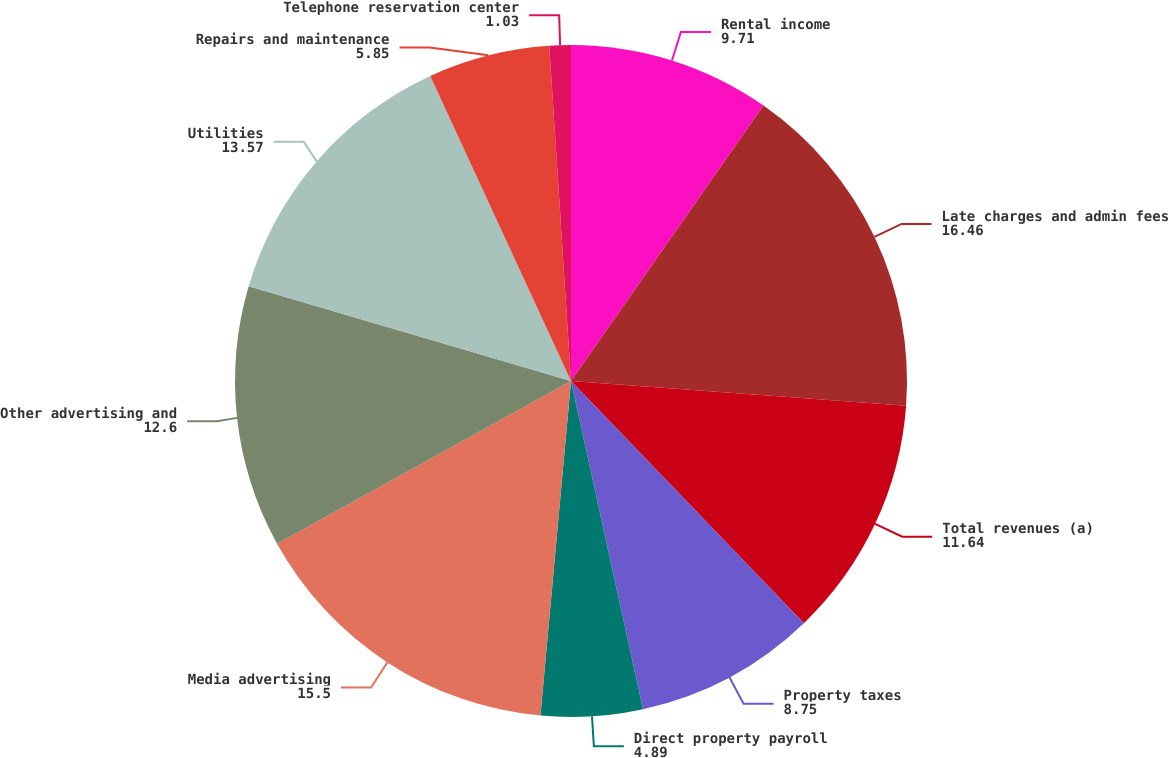Convert chart. <chart><loc_0><loc_0><loc_500><loc_500><pie_chart><fcel>Rental income<fcel>Late charges and admin fees<fcel>Total revenues (a)<fcel>Property taxes<fcel>Direct property payroll<fcel>Media advertising<fcel>Other advertising and<fcel>Utilities<fcel>Repairs and maintenance<fcel>Telephone reservation center<nl><fcel>9.71%<fcel>16.46%<fcel>11.64%<fcel>8.75%<fcel>4.89%<fcel>15.5%<fcel>12.6%<fcel>13.57%<fcel>5.85%<fcel>1.03%<nl></chart> 